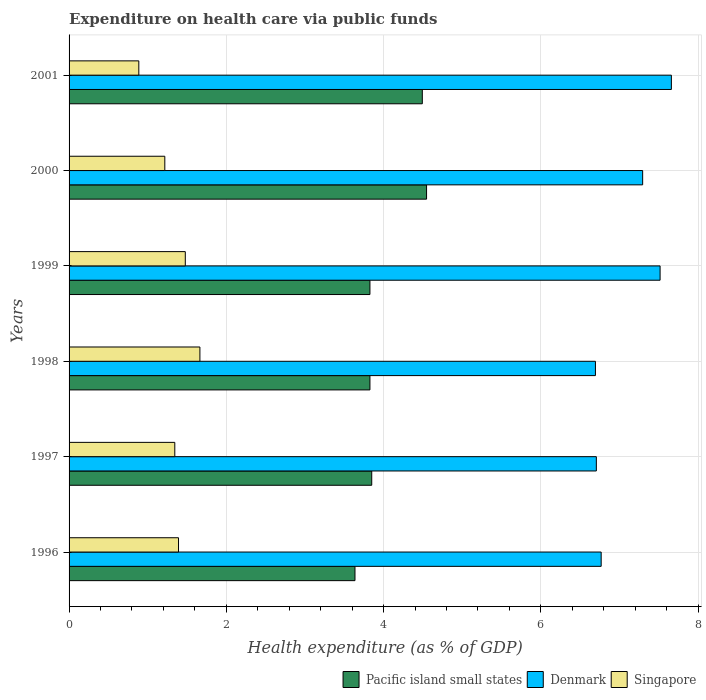Are the number of bars per tick equal to the number of legend labels?
Your answer should be compact. Yes. Are the number of bars on each tick of the Y-axis equal?
Offer a terse response. Yes. In how many cases, is the number of bars for a given year not equal to the number of legend labels?
Make the answer very short. 0. What is the expenditure made on health care in Singapore in 1998?
Your answer should be very brief. 1.66. Across all years, what is the maximum expenditure made on health care in Singapore?
Keep it short and to the point. 1.66. Across all years, what is the minimum expenditure made on health care in Singapore?
Your response must be concise. 0.89. In which year was the expenditure made on health care in Pacific island small states minimum?
Provide a short and direct response. 1996. What is the total expenditure made on health care in Singapore in the graph?
Your response must be concise. 7.98. What is the difference between the expenditure made on health care in Singapore in 1999 and that in 2000?
Ensure brevity in your answer.  0.26. What is the difference between the expenditure made on health care in Denmark in 2000 and the expenditure made on health care in Pacific island small states in 2001?
Offer a terse response. 2.8. What is the average expenditure made on health care in Pacific island small states per year?
Your answer should be very brief. 4.03. In the year 1999, what is the difference between the expenditure made on health care in Denmark and expenditure made on health care in Singapore?
Your response must be concise. 6.04. In how many years, is the expenditure made on health care in Denmark greater than 0.4 %?
Give a very brief answer. 6. What is the ratio of the expenditure made on health care in Pacific island small states in 1996 to that in 1998?
Your answer should be compact. 0.95. Is the difference between the expenditure made on health care in Denmark in 1998 and 2001 greater than the difference between the expenditure made on health care in Singapore in 1998 and 2001?
Keep it short and to the point. No. What is the difference between the highest and the second highest expenditure made on health care in Denmark?
Ensure brevity in your answer.  0.14. What is the difference between the highest and the lowest expenditure made on health care in Pacific island small states?
Give a very brief answer. 0.91. In how many years, is the expenditure made on health care in Pacific island small states greater than the average expenditure made on health care in Pacific island small states taken over all years?
Provide a short and direct response. 2. What does the 3rd bar from the bottom in 2000 represents?
Your answer should be very brief. Singapore. Is it the case that in every year, the sum of the expenditure made on health care in Singapore and expenditure made on health care in Denmark is greater than the expenditure made on health care in Pacific island small states?
Your answer should be very brief. Yes. How many bars are there?
Ensure brevity in your answer.  18. How many years are there in the graph?
Your answer should be very brief. 6. Are the values on the major ticks of X-axis written in scientific E-notation?
Provide a short and direct response. No. Does the graph contain grids?
Your response must be concise. Yes. Where does the legend appear in the graph?
Offer a very short reply. Bottom right. How many legend labels are there?
Provide a succinct answer. 3. What is the title of the graph?
Your answer should be compact. Expenditure on health care via public funds. Does "Caribbean small states" appear as one of the legend labels in the graph?
Offer a very short reply. No. What is the label or title of the X-axis?
Provide a short and direct response. Health expenditure (as % of GDP). What is the Health expenditure (as % of GDP) of Pacific island small states in 1996?
Your response must be concise. 3.64. What is the Health expenditure (as % of GDP) in Denmark in 1996?
Provide a succinct answer. 6.77. What is the Health expenditure (as % of GDP) of Singapore in 1996?
Make the answer very short. 1.39. What is the Health expenditure (as % of GDP) of Pacific island small states in 1997?
Provide a short and direct response. 3.85. What is the Health expenditure (as % of GDP) in Denmark in 1997?
Offer a very short reply. 6.71. What is the Health expenditure (as % of GDP) of Singapore in 1997?
Your answer should be very brief. 1.34. What is the Health expenditure (as % of GDP) of Pacific island small states in 1998?
Your response must be concise. 3.83. What is the Health expenditure (as % of GDP) of Denmark in 1998?
Your answer should be compact. 6.69. What is the Health expenditure (as % of GDP) of Singapore in 1998?
Make the answer very short. 1.66. What is the Health expenditure (as % of GDP) in Pacific island small states in 1999?
Provide a succinct answer. 3.83. What is the Health expenditure (as % of GDP) in Denmark in 1999?
Make the answer very short. 7.52. What is the Health expenditure (as % of GDP) of Singapore in 1999?
Your answer should be compact. 1.48. What is the Health expenditure (as % of GDP) in Pacific island small states in 2000?
Your answer should be compact. 4.55. What is the Health expenditure (as % of GDP) in Denmark in 2000?
Provide a short and direct response. 7.3. What is the Health expenditure (as % of GDP) of Singapore in 2000?
Keep it short and to the point. 1.22. What is the Health expenditure (as % of GDP) in Pacific island small states in 2001?
Your answer should be very brief. 4.49. What is the Health expenditure (as % of GDP) of Denmark in 2001?
Give a very brief answer. 7.66. What is the Health expenditure (as % of GDP) of Singapore in 2001?
Make the answer very short. 0.89. Across all years, what is the maximum Health expenditure (as % of GDP) of Pacific island small states?
Provide a succinct answer. 4.55. Across all years, what is the maximum Health expenditure (as % of GDP) of Denmark?
Provide a short and direct response. 7.66. Across all years, what is the maximum Health expenditure (as % of GDP) of Singapore?
Ensure brevity in your answer.  1.66. Across all years, what is the minimum Health expenditure (as % of GDP) in Pacific island small states?
Offer a terse response. 3.64. Across all years, what is the minimum Health expenditure (as % of GDP) in Denmark?
Your response must be concise. 6.69. Across all years, what is the minimum Health expenditure (as % of GDP) of Singapore?
Offer a very short reply. 0.89. What is the total Health expenditure (as % of GDP) of Pacific island small states in the graph?
Ensure brevity in your answer.  24.18. What is the total Health expenditure (as % of GDP) in Denmark in the graph?
Provide a short and direct response. 42.64. What is the total Health expenditure (as % of GDP) of Singapore in the graph?
Give a very brief answer. 7.98. What is the difference between the Health expenditure (as % of GDP) in Pacific island small states in 1996 and that in 1997?
Keep it short and to the point. -0.21. What is the difference between the Health expenditure (as % of GDP) in Denmark in 1996 and that in 1997?
Offer a very short reply. 0.06. What is the difference between the Health expenditure (as % of GDP) of Singapore in 1996 and that in 1997?
Your response must be concise. 0.05. What is the difference between the Health expenditure (as % of GDP) in Pacific island small states in 1996 and that in 1998?
Your answer should be very brief. -0.19. What is the difference between the Health expenditure (as % of GDP) in Denmark in 1996 and that in 1998?
Provide a succinct answer. 0.07. What is the difference between the Health expenditure (as % of GDP) of Singapore in 1996 and that in 1998?
Keep it short and to the point. -0.27. What is the difference between the Health expenditure (as % of GDP) of Pacific island small states in 1996 and that in 1999?
Your response must be concise. -0.19. What is the difference between the Health expenditure (as % of GDP) of Denmark in 1996 and that in 1999?
Offer a terse response. -0.75. What is the difference between the Health expenditure (as % of GDP) of Singapore in 1996 and that in 1999?
Give a very brief answer. -0.09. What is the difference between the Health expenditure (as % of GDP) in Pacific island small states in 1996 and that in 2000?
Offer a very short reply. -0.91. What is the difference between the Health expenditure (as % of GDP) of Denmark in 1996 and that in 2000?
Ensure brevity in your answer.  -0.53. What is the difference between the Health expenditure (as % of GDP) of Singapore in 1996 and that in 2000?
Make the answer very short. 0.17. What is the difference between the Health expenditure (as % of GDP) of Pacific island small states in 1996 and that in 2001?
Provide a succinct answer. -0.86. What is the difference between the Health expenditure (as % of GDP) in Denmark in 1996 and that in 2001?
Your answer should be very brief. -0.89. What is the difference between the Health expenditure (as % of GDP) in Singapore in 1996 and that in 2001?
Your response must be concise. 0.5. What is the difference between the Health expenditure (as % of GDP) of Pacific island small states in 1997 and that in 1998?
Offer a very short reply. 0.02. What is the difference between the Health expenditure (as % of GDP) in Denmark in 1997 and that in 1998?
Ensure brevity in your answer.  0.01. What is the difference between the Health expenditure (as % of GDP) in Singapore in 1997 and that in 1998?
Keep it short and to the point. -0.32. What is the difference between the Health expenditure (as % of GDP) in Pacific island small states in 1997 and that in 1999?
Your answer should be very brief. 0.02. What is the difference between the Health expenditure (as % of GDP) of Denmark in 1997 and that in 1999?
Ensure brevity in your answer.  -0.81. What is the difference between the Health expenditure (as % of GDP) in Singapore in 1997 and that in 1999?
Your answer should be compact. -0.13. What is the difference between the Health expenditure (as % of GDP) in Pacific island small states in 1997 and that in 2000?
Keep it short and to the point. -0.7. What is the difference between the Health expenditure (as % of GDP) in Denmark in 1997 and that in 2000?
Keep it short and to the point. -0.59. What is the difference between the Health expenditure (as % of GDP) in Singapore in 1997 and that in 2000?
Provide a short and direct response. 0.13. What is the difference between the Health expenditure (as % of GDP) in Pacific island small states in 1997 and that in 2001?
Provide a succinct answer. -0.64. What is the difference between the Health expenditure (as % of GDP) in Denmark in 1997 and that in 2001?
Keep it short and to the point. -0.95. What is the difference between the Health expenditure (as % of GDP) in Singapore in 1997 and that in 2001?
Your answer should be compact. 0.46. What is the difference between the Health expenditure (as % of GDP) of Pacific island small states in 1998 and that in 1999?
Offer a very short reply. -0. What is the difference between the Health expenditure (as % of GDP) of Denmark in 1998 and that in 1999?
Ensure brevity in your answer.  -0.82. What is the difference between the Health expenditure (as % of GDP) of Singapore in 1998 and that in 1999?
Your answer should be very brief. 0.19. What is the difference between the Health expenditure (as % of GDP) of Pacific island small states in 1998 and that in 2000?
Your response must be concise. -0.72. What is the difference between the Health expenditure (as % of GDP) of Denmark in 1998 and that in 2000?
Offer a very short reply. -0.6. What is the difference between the Health expenditure (as % of GDP) in Singapore in 1998 and that in 2000?
Offer a terse response. 0.45. What is the difference between the Health expenditure (as % of GDP) of Pacific island small states in 1998 and that in 2001?
Offer a very short reply. -0.67. What is the difference between the Health expenditure (as % of GDP) in Denmark in 1998 and that in 2001?
Your answer should be very brief. -0.97. What is the difference between the Health expenditure (as % of GDP) in Singapore in 1998 and that in 2001?
Offer a terse response. 0.78. What is the difference between the Health expenditure (as % of GDP) of Pacific island small states in 1999 and that in 2000?
Your answer should be very brief. -0.72. What is the difference between the Health expenditure (as % of GDP) in Denmark in 1999 and that in 2000?
Give a very brief answer. 0.22. What is the difference between the Health expenditure (as % of GDP) of Singapore in 1999 and that in 2000?
Your answer should be very brief. 0.26. What is the difference between the Health expenditure (as % of GDP) of Pacific island small states in 1999 and that in 2001?
Make the answer very short. -0.67. What is the difference between the Health expenditure (as % of GDP) of Denmark in 1999 and that in 2001?
Give a very brief answer. -0.14. What is the difference between the Health expenditure (as % of GDP) of Singapore in 1999 and that in 2001?
Your answer should be very brief. 0.59. What is the difference between the Health expenditure (as % of GDP) of Pacific island small states in 2000 and that in 2001?
Offer a very short reply. 0.05. What is the difference between the Health expenditure (as % of GDP) in Denmark in 2000 and that in 2001?
Offer a very short reply. -0.37. What is the difference between the Health expenditure (as % of GDP) of Singapore in 2000 and that in 2001?
Your answer should be very brief. 0.33. What is the difference between the Health expenditure (as % of GDP) in Pacific island small states in 1996 and the Health expenditure (as % of GDP) in Denmark in 1997?
Your answer should be very brief. -3.07. What is the difference between the Health expenditure (as % of GDP) in Pacific island small states in 1996 and the Health expenditure (as % of GDP) in Singapore in 1997?
Keep it short and to the point. 2.29. What is the difference between the Health expenditure (as % of GDP) of Denmark in 1996 and the Health expenditure (as % of GDP) of Singapore in 1997?
Offer a very short reply. 5.42. What is the difference between the Health expenditure (as % of GDP) of Pacific island small states in 1996 and the Health expenditure (as % of GDP) of Denmark in 1998?
Your answer should be very brief. -3.06. What is the difference between the Health expenditure (as % of GDP) of Pacific island small states in 1996 and the Health expenditure (as % of GDP) of Singapore in 1998?
Offer a very short reply. 1.97. What is the difference between the Health expenditure (as % of GDP) in Denmark in 1996 and the Health expenditure (as % of GDP) in Singapore in 1998?
Keep it short and to the point. 5.1. What is the difference between the Health expenditure (as % of GDP) in Pacific island small states in 1996 and the Health expenditure (as % of GDP) in Denmark in 1999?
Provide a short and direct response. -3.88. What is the difference between the Health expenditure (as % of GDP) in Pacific island small states in 1996 and the Health expenditure (as % of GDP) in Singapore in 1999?
Keep it short and to the point. 2.16. What is the difference between the Health expenditure (as % of GDP) in Denmark in 1996 and the Health expenditure (as % of GDP) in Singapore in 1999?
Your answer should be compact. 5.29. What is the difference between the Health expenditure (as % of GDP) in Pacific island small states in 1996 and the Health expenditure (as % of GDP) in Denmark in 2000?
Provide a succinct answer. -3.66. What is the difference between the Health expenditure (as % of GDP) of Pacific island small states in 1996 and the Health expenditure (as % of GDP) of Singapore in 2000?
Provide a short and direct response. 2.42. What is the difference between the Health expenditure (as % of GDP) of Denmark in 1996 and the Health expenditure (as % of GDP) of Singapore in 2000?
Your response must be concise. 5.55. What is the difference between the Health expenditure (as % of GDP) in Pacific island small states in 1996 and the Health expenditure (as % of GDP) in Denmark in 2001?
Keep it short and to the point. -4.02. What is the difference between the Health expenditure (as % of GDP) in Pacific island small states in 1996 and the Health expenditure (as % of GDP) in Singapore in 2001?
Provide a short and direct response. 2.75. What is the difference between the Health expenditure (as % of GDP) in Denmark in 1996 and the Health expenditure (as % of GDP) in Singapore in 2001?
Provide a short and direct response. 5.88. What is the difference between the Health expenditure (as % of GDP) in Pacific island small states in 1997 and the Health expenditure (as % of GDP) in Denmark in 1998?
Ensure brevity in your answer.  -2.85. What is the difference between the Health expenditure (as % of GDP) of Pacific island small states in 1997 and the Health expenditure (as % of GDP) of Singapore in 1998?
Give a very brief answer. 2.19. What is the difference between the Health expenditure (as % of GDP) in Denmark in 1997 and the Health expenditure (as % of GDP) in Singapore in 1998?
Offer a very short reply. 5.04. What is the difference between the Health expenditure (as % of GDP) of Pacific island small states in 1997 and the Health expenditure (as % of GDP) of Denmark in 1999?
Give a very brief answer. -3.67. What is the difference between the Health expenditure (as % of GDP) in Pacific island small states in 1997 and the Health expenditure (as % of GDP) in Singapore in 1999?
Make the answer very short. 2.37. What is the difference between the Health expenditure (as % of GDP) of Denmark in 1997 and the Health expenditure (as % of GDP) of Singapore in 1999?
Offer a terse response. 5.23. What is the difference between the Health expenditure (as % of GDP) of Pacific island small states in 1997 and the Health expenditure (as % of GDP) of Denmark in 2000?
Your answer should be very brief. -3.45. What is the difference between the Health expenditure (as % of GDP) of Pacific island small states in 1997 and the Health expenditure (as % of GDP) of Singapore in 2000?
Offer a very short reply. 2.63. What is the difference between the Health expenditure (as % of GDP) of Denmark in 1997 and the Health expenditure (as % of GDP) of Singapore in 2000?
Your answer should be very brief. 5.49. What is the difference between the Health expenditure (as % of GDP) of Pacific island small states in 1997 and the Health expenditure (as % of GDP) of Denmark in 2001?
Give a very brief answer. -3.81. What is the difference between the Health expenditure (as % of GDP) in Pacific island small states in 1997 and the Health expenditure (as % of GDP) in Singapore in 2001?
Provide a succinct answer. 2.96. What is the difference between the Health expenditure (as % of GDP) of Denmark in 1997 and the Health expenditure (as % of GDP) of Singapore in 2001?
Offer a terse response. 5.82. What is the difference between the Health expenditure (as % of GDP) in Pacific island small states in 1998 and the Health expenditure (as % of GDP) in Denmark in 1999?
Give a very brief answer. -3.69. What is the difference between the Health expenditure (as % of GDP) of Pacific island small states in 1998 and the Health expenditure (as % of GDP) of Singapore in 1999?
Offer a terse response. 2.35. What is the difference between the Health expenditure (as % of GDP) of Denmark in 1998 and the Health expenditure (as % of GDP) of Singapore in 1999?
Your answer should be very brief. 5.22. What is the difference between the Health expenditure (as % of GDP) in Pacific island small states in 1998 and the Health expenditure (as % of GDP) in Denmark in 2000?
Provide a succinct answer. -3.47. What is the difference between the Health expenditure (as % of GDP) of Pacific island small states in 1998 and the Health expenditure (as % of GDP) of Singapore in 2000?
Keep it short and to the point. 2.61. What is the difference between the Health expenditure (as % of GDP) of Denmark in 1998 and the Health expenditure (as % of GDP) of Singapore in 2000?
Ensure brevity in your answer.  5.48. What is the difference between the Health expenditure (as % of GDP) of Pacific island small states in 1998 and the Health expenditure (as % of GDP) of Denmark in 2001?
Give a very brief answer. -3.83. What is the difference between the Health expenditure (as % of GDP) in Pacific island small states in 1998 and the Health expenditure (as % of GDP) in Singapore in 2001?
Offer a terse response. 2.94. What is the difference between the Health expenditure (as % of GDP) in Denmark in 1998 and the Health expenditure (as % of GDP) in Singapore in 2001?
Your response must be concise. 5.81. What is the difference between the Health expenditure (as % of GDP) in Pacific island small states in 1999 and the Health expenditure (as % of GDP) in Denmark in 2000?
Offer a very short reply. -3.47. What is the difference between the Health expenditure (as % of GDP) in Pacific island small states in 1999 and the Health expenditure (as % of GDP) in Singapore in 2000?
Keep it short and to the point. 2.61. What is the difference between the Health expenditure (as % of GDP) of Denmark in 1999 and the Health expenditure (as % of GDP) of Singapore in 2000?
Keep it short and to the point. 6.3. What is the difference between the Health expenditure (as % of GDP) in Pacific island small states in 1999 and the Health expenditure (as % of GDP) in Denmark in 2001?
Offer a terse response. -3.83. What is the difference between the Health expenditure (as % of GDP) of Pacific island small states in 1999 and the Health expenditure (as % of GDP) of Singapore in 2001?
Keep it short and to the point. 2.94. What is the difference between the Health expenditure (as % of GDP) of Denmark in 1999 and the Health expenditure (as % of GDP) of Singapore in 2001?
Your answer should be compact. 6.63. What is the difference between the Health expenditure (as % of GDP) in Pacific island small states in 2000 and the Health expenditure (as % of GDP) in Denmark in 2001?
Your response must be concise. -3.11. What is the difference between the Health expenditure (as % of GDP) in Pacific island small states in 2000 and the Health expenditure (as % of GDP) in Singapore in 2001?
Make the answer very short. 3.66. What is the difference between the Health expenditure (as % of GDP) of Denmark in 2000 and the Health expenditure (as % of GDP) of Singapore in 2001?
Your answer should be compact. 6.41. What is the average Health expenditure (as % of GDP) in Pacific island small states per year?
Your answer should be compact. 4.03. What is the average Health expenditure (as % of GDP) in Denmark per year?
Offer a very short reply. 7.11. What is the average Health expenditure (as % of GDP) of Singapore per year?
Offer a terse response. 1.33. In the year 1996, what is the difference between the Health expenditure (as % of GDP) of Pacific island small states and Health expenditure (as % of GDP) of Denmark?
Provide a short and direct response. -3.13. In the year 1996, what is the difference between the Health expenditure (as % of GDP) in Pacific island small states and Health expenditure (as % of GDP) in Singapore?
Your answer should be very brief. 2.24. In the year 1996, what is the difference between the Health expenditure (as % of GDP) of Denmark and Health expenditure (as % of GDP) of Singapore?
Provide a short and direct response. 5.38. In the year 1997, what is the difference between the Health expenditure (as % of GDP) of Pacific island small states and Health expenditure (as % of GDP) of Denmark?
Offer a very short reply. -2.86. In the year 1997, what is the difference between the Health expenditure (as % of GDP) in Pacific island small states and Health expenditure (as % of GDP) in Singapore?
Give a very brief answer. 2.5. In the year 1997, what is the difference between the Health expenditure (as % of GDP) of Denmark and Health expenditure (as % of GDP) of Singapore?
Give a very brief answer. 5.36. In the year 1998, what is the difference between the Health expenditure (as % of GDP) in Pacific island small states and Health expenditure (as % of GDP) in Denmark?
Provide a short and direct response. -2.87. In the year 1998, what is the difference between the Health expenditure (as % of GDP) in Pacific island small states and Health expenditure (as % of GDP) in Singapore?
Provide a short and direct response. 2.16. In the year 1998, what is the difference between the Health expenditure (as % of GDP) of Denmark and Health expenditure (as % of GDP) of Singapore?
Your response must be concise. 5.03. In the year 1999, what is the difference between the Health expenditure (as % of GDP) of Pacific island small states and Health expenditure (as % of GDP) of Denmark?
Offer a terse response. -3.69. In the year 1999, what is the difference between the Health expenditure (as % of GDP) of Pacific island small states and Health expenditure (as % of GDP) of Singapore?
Your response must be concise. 2.35. In the year 1999, what is the difference between the Health expenditure (as % of GDP) of Denmark and Health expenditure (as % of GDP) of Singapore?
Your answer should be compact. 6.04. In the year 2000, what is the difference between the Health expenditure (as % of GDP) in Pacific island small states and Health expenditure (as % of GDP) in Denmark?
Your answer should be compact. -2.75. In the year 2000, what is the difference between the Health expenditure (as % of GDP) of Pacific island small states and Health expenditure (as % of GDP) of Singapore?
Your response must be concise. 3.33. In the year 2000, what is the difference between the Health expenditure (as % of GDP) of Denmark and Health expenditure (as % of GDP) of Singapore?
Your answer should be very brief. 6.08. In the year 2001, what is the difference between the Health expenditure (as % of GDP) of Pacific island small states and Health expenditure (as % of GDP) of Denmark?
Your response must be concise. -3.17. In the year 2001, what is the difference between the Health expenditure (as % of GDP) in Pacific island small states and Health expenditure (as % of GDP) in Singapore?
Offer a terse response. 3.61. In the year 2001, what is the difference between the Health expenditure (as % of GDP) in Denmark and Health expenditure (as % of GDP) in Singapore?
Your response must be concise. 6.77. What is the ratio of the Health expenditure (as % of GDP) of Pacific island small states in 1996 to that in 1997?
Keep it short and to the point. 0.94. What is the ratio of the Health expenditure (as % of GDP) of Denmark in 1996 to that in 1997?
Provide a succinct answer. 1.01. What is the ratio of the Health expenditure (as % of GDP) in Singapore in 1996 to that in 1997?
Your answer should be compact. 1.03. What is the ratio of the Health expenditure (as % of GDP) of Pacific island small states in 1996 to that in 1998?
Offer a very short reply. 0.95. What is the ratio of the Health expenditure (as % of GDP) in Denmark in 1996 to that in 1998?
Ensure brevity in your answer.  1.01. What is the ratio of the Health expenditure (as % of GDP) of Singapore in 1996 to that in 1998?
Provide a short and direct response. 0.84. What is the ratio of the Health expenditure (as % of GDP) in Pacific island small states in 1996 to that in 1999?
Ensure brevity in your answer.  0.95. What is the ratio of the Health expenditure (as % of GDP) in Denmark in 1996 to that in 1999?
Provide a short and direct response. 0.9. What is the ratio of the Health expenditure (as % of GDP) in Singapore in 1996 to that in 1999?
Provide a short and direct response. 0.94. What is the ratio of the Health expenditure (as % of GDP) in Pacific island small states in 1996 to that in 2000?
Provide a succinct answer. 0.8. What is the ratio of the Health expenditure (as % of GDP) of Denmark in 1996 to that in 2000?
Make the answer very short. 0.93. What is the ratio of the Health expenditure (as % of GDP) of Singapore in 1996 to that in 2000?
Your answer should be compact. 1.14. What is the ratio of the Health expenditure (as % of GDP) of Pacific island small states in 1996 to that in 2001?
Make the answer very short. 0.81. What is the ratio of the Health expenditure (as % of GDP) in Denmark in 1996 to that in 2001?
Your answer should be very brief. 0.88. What is the ratio of the Health expenditure (as % of GDP) of Singapore in 1996 to that in 2001?
Offer a very short reply. 1.57. What is the ratio of the Health expenditure (as % of GDP) in Pacific island small states in 1997 to that in 1998?
Your answer should be very brief. 1.01. What is the ratio of the Health expenditure (as % of GDP) of Denmark in 1997 to that in 1998?
Make the answer very short. 1. What is the ratio of the Health expenditure (as % of GDP) in Singapore in 1997 to that in 1998?
Provide a succinct answer. 0.81. What is the ratio of the Health expenditure (as % of GDP) of Pacific island small states in 1997 to that in 1999?
Keep it short and to the point. 1.01. What is the ratio of the Health expenditure (as % of GDP) in Denmark in 1997 to that in 1999?
Offer a very short reply. 0.89. What is the ratio of the Health expenditure (as % of GDP) in Singapore in 1997 to that in 1999?
Make the answer very short. 0.91. What is the ratio of the Health expenditure (as % of GDP) in Pacific island small states in 1997 to that in 2000?
Provide a succinct answer. 0.85. What is the ratio of the Health expenditure (as % of GDP) of Denmark in 1997 to that in 2000?
Your answer should be very brief. 0.92. What is the ratio of the Health expenditure (as % of GDP) in Singapore in 1997 to that in 2000?
Make the answer very short. 1.1. What is the ratio of the Health expenditure (as % of GDP) in Pacific island small states in 1997 to that in 2001?
Ensure brevity in your answer.  0.86. What is the ratio of the Health expenditure (as % of GDP) of Denmark in 1997 to that in 2001?
Provide a succinct answer. 0.88. What is the ratio of the Health expenditure (as % of GDP) in Singapore in 1997 to that in 2001?
Your response must be concise. 1.52. What is the ratio of the Health expenditure (as % of GDP) of Denmark in 1998 to that in 1999?
Provide a succinct answer. 0.89. What is the ratio of the Health expenditure (as % of GDP) of Singapore in 1998 to that in 1999?
Make the answer very short. 1.13. What is the ratio of the Health expenditure (as % of GDP) in Pacific island small states in 1998 to that in 2000?
Provide a short and direct response. 0.84. What is the ratio of the Health expenditure (as % of GDP) of Denmark in 1998 to that in 2000?
Your answer should be compact. 0.92. What is the ratio of the Health expenditure (as % of GDP) in Singapore in 1998 to that in 2000?
Keep it short and to the point. 1.37. What is the ratio of the Health expenditure (as % of GDP) of Pacific island small states in 1998 to that in 2001?
Your answer should be very brief. 0.85. What is the ratio of the Health expenditure (as % of GDP) in Denmark in 1998 to that in 2001?
Offer a terse response. 0.87. What is the ratio of the Health expenditure (as % of GDP) of Singapore in 1998 to that in 2001?
Your answer should be compact. 1.88. What is the ratio of the Health expenditure (as % of GDP) of Pacific island small states in 1999 to that in 2000?
Your answer should be compact. 0.84. What is the ratio of the Health expenditure (as % of GDP) of Denmark in 1999 to that in 2000?
Make the answer very short. 1.03. What is the ratio of the Health expenditure (as % of GDP) of Singapore in 1999 to that in 2000?
Make the answer very short. 1.21. What is the ratio of the Health expenditure (as % of GDP) of Pacific island small states in 1999 to that in 2001?
Keep it short and to the point. 0.85. What is the ratio of the Health expenditure (as % of GDP) in Denmark in 1999 to that in 2001?
Ensure brevity in your answer.  0.98. What is the ratio of the Health expenditure (as % of GDP) in Singapore in 1999 to that in 2001?
Offer a very short reply. 1.67. What is the ratio of the Health expenditure (as % of GDP) in Pacific island small states in 2000 to that in 2001?
Keep it short and to the point. 1.01. What is the ratio of the Health expenditure (as % of GDP) in Denmark in 2000 to that in 2001?
Your answer should be very brief. 0.95. What is the ratio of the Health expenditure (as % of GDP) in Singapore in 2000 to that in 2001?
Provide a short and direct response. 1.37. What is the difference between the highest and the second highest Health expenditure (as % of GDP) in Pacific island small states?
Your answer should be very brief. 0.05. What is the difference between the highest and the second highest Health expenditure (as % of GDP) in Denmark?
Make the answer very short. 0.14. What is the difference between the highest and the second highest Health expenditure (as % of GDP) of Singapore?
Your answer should be compact. 0.19. What is the difference between the highest and the lowest Health expenditure (as % of GDP) of Pacific island small states?
Provide a short and direct response. 0.91. What is the difference between the highest and the lowest Health expenditure (as % of GDP) in Denmark?
Offer a terse response. 0.97. What is the difference between the highest and the lowest Health expenditure (as % of GDP) of Singapore?
Ensure brevity in your answer.  0.78. 